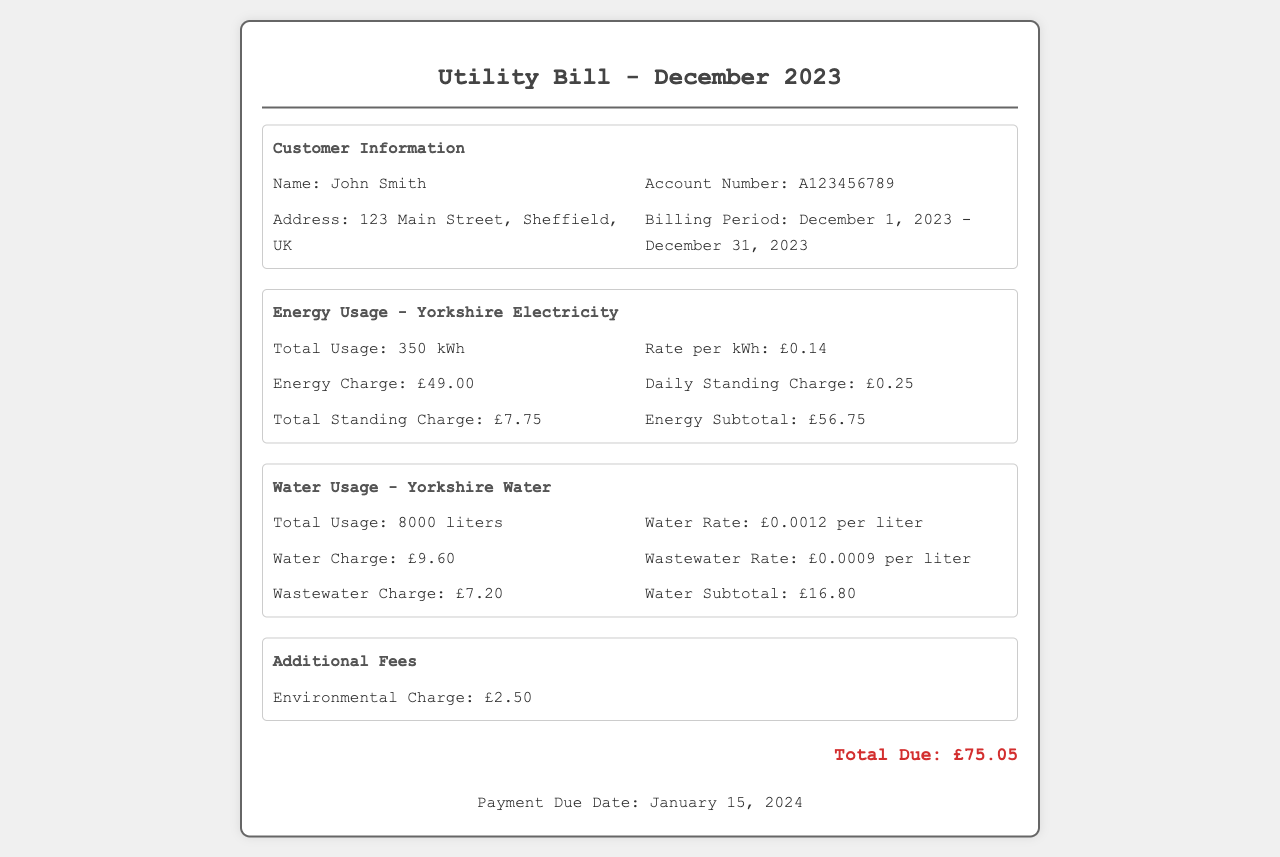What is the total energy usage? The total energy usage is stated in the document under the energy section as 350 kWh.
Answer: 350 kWh What is the water charge rate? The document specifies the water charge rate as £0.0012 per liter in the water usage section.
Answer: £0.0012 per liter What is the total amount due? The total due is summarized at the bottom of the document as £75.05.
Answer: £75.05 What is the billing period? The billing period is provided under customer information as December 1, 2023 - December 31, 2023.
Answer: December 1, 2023 - December 31, 2023 How much is the environmental charge? The environmental charge is listed in the additional fees section as £2.50.
Answer: £2.50 What is the water usage in liters? The total water usage is indicated as 8000 liters in the water usage section.
Answer: 8000 liters What is the rate for wastewater charge? The document states the wastewater rate as £0.0009 per liter under the water usage section.
Answer: £0.0009 per liter What is the daily standing charge for energy? The daily standing charge for energy is stated as £0.25 in the energy usage section of the document.
Answer: £0.25 What is the due date for payment? The payment due date is mentioned at the bottom of the document as January 15, 2024.
Answer: January 15, 2024 